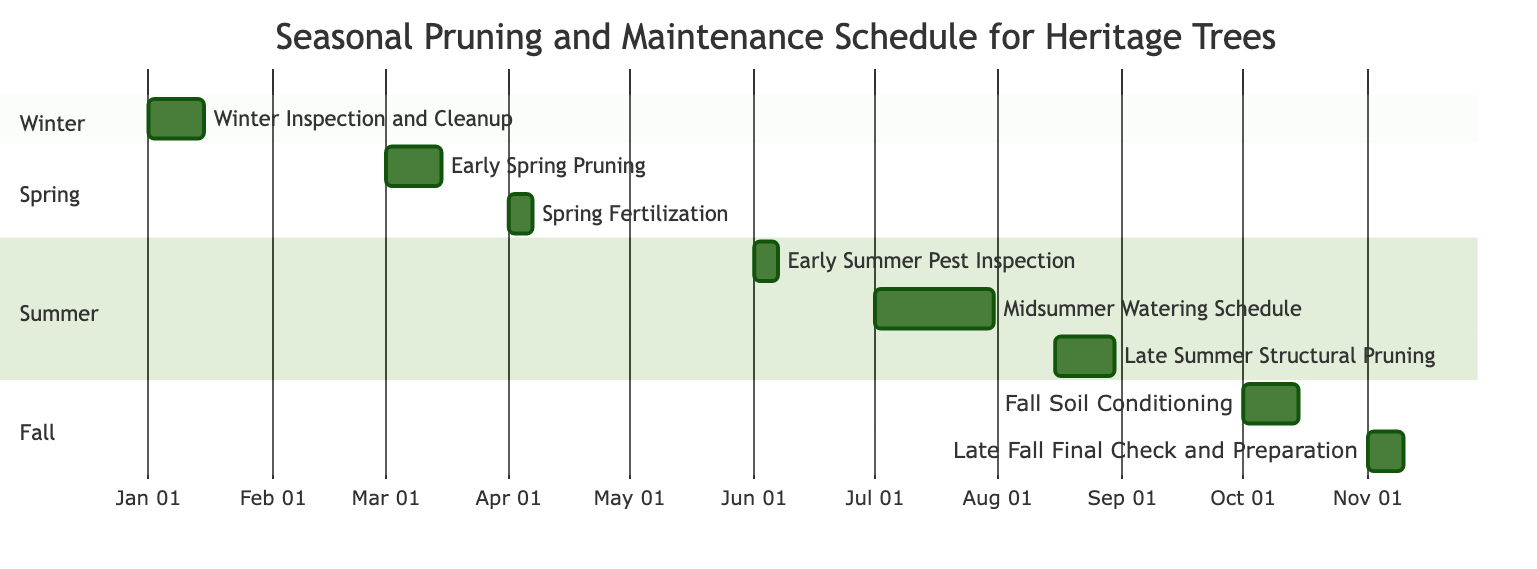What is the duration of Winter Inspection and Cleanup? The Winter Inspection and Cleanup task starts on January 1, 2023, and ends on January 15, 2023. The duration is calculated by counting the number of days from the start to the end date, which is 15 days.
Answer: 15 days Which task follows Early Spring Pruning? Looking at the Gantt chart, after Early Spring Pruning, which runs from March 1 to March 15, the next task is Spring Fertilization, starting on April 1.
Answer: Spring Fertilization How many tasks are scheduled in Summer? There are three tasks listed under the Summer section in the Gantt chart: Early Summer Pest Inspection, Midsummer Watering Schedule, and Late Summer Structural Pruning. Therefore, the total number of tasks for Summer is three.
Answer: 3 What month does Fall Soil Conditioning begin? The Fall Soil Conditioning task begins on October 1, 2023. Looking at the start date of this task, we can identify that it is in the month of October.
Answer: October Which task overlaps with Midsummer Watering Schedule? Since the Midsummer Watering Schedule runs from July 1 to July 31, we look at adjacent tasks. There are no tasks overlapping because both Early Summer Pest Inspection and Late Summer Structural Pruning are in different months and do not share any common days.
Answer: None What is the last task in the schedule? By examining the Gantt chart, the final task is Late Fall Final Check and Preparation, which runs from November 1 to November 10.
Answer: Late Fall Final Check and Preparation Which season has the longest individual task duration? Comparing the durations of each task, we find that the Midsummer Watering Schedule runs for the entire month of July, totaling 31 days, which is longer than any other task duration listed under the other seasons.
Answer: Midsummer Watering Schedule What is the timing for Early Summer Pest Inspection? Early Summer Pest Inspection is scheduled from June 1 to June 7, 2023. This is confirmed by both the start and end dates given for this task in the Gantt chart.
Answer: June 1 to June 7 Which tree is focused on in early spring activities? The Early Spring Pruning task, which is the prominent activity during the early spring, includes deciduous trees such as the Grand Maple and Towering Beech, indicating that these are the trees of focus in the early spring period.
Answer: Grand Maple, Towering Beech 